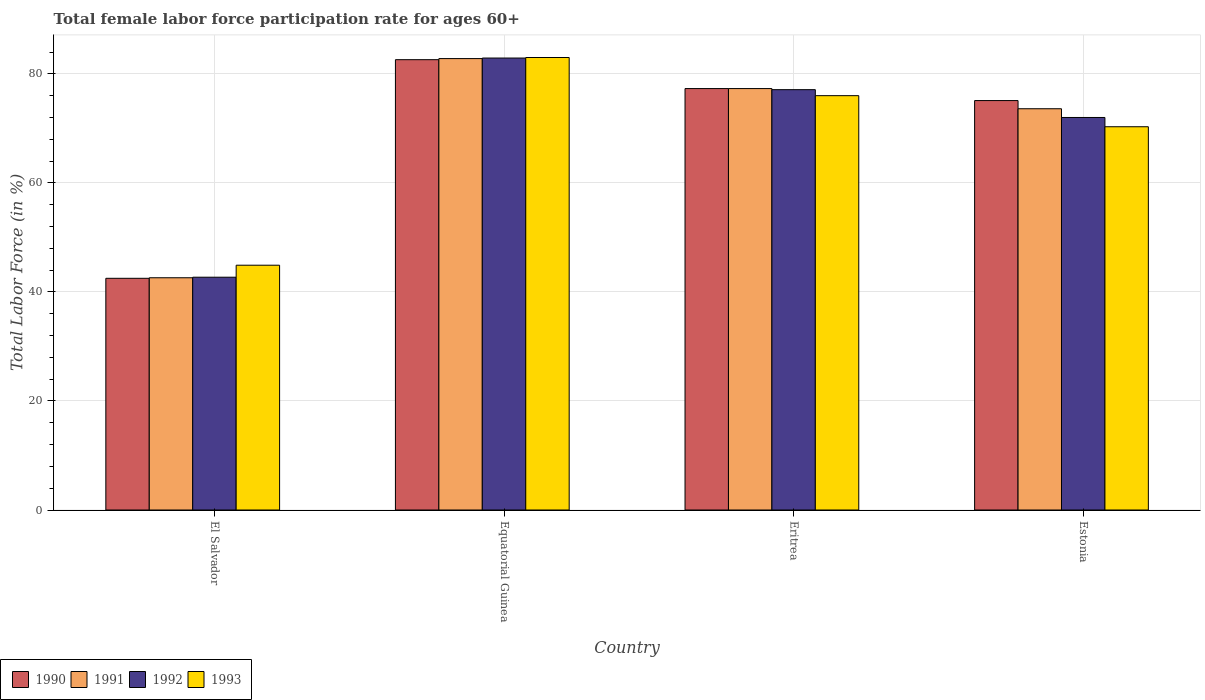How many different coloured bars are there?
Provide a succinct answer. 4. How many groups of bars are there?
Your answer should be compact. 4. Are the number of bars per tick equal to the number of legend labels?
Ensure brevity in your answer.  Yes. How many bars are there on the 1st tick from the right?
Offer a terse response. 4. What is the label of the 1st group of bars from the left?
Your answer should be very brief. El Salvador. In how many cases, is the number of bars for a given country not equal to the number of legend labels?
Offer a terse response. 0. What is the female labor force participation rate in 1992 in Equatorial Guinea?
Make the answer very short. 82.9. Across all countries, what is the minimum female labor force participation rate in 1990?
Your answer should be very brief. 42.5. In which country was the female labor force participation rate in 1990 maximum?
Offer a very short reply. Equatorial Guinea. In which country was the female labor force participation rate in 1993 minimum?
Your response must be concise. El Salvador. What is the total female labor force participation rate in 1992 in the graph?
Keep it short and to the point. 274.7. What is the difference between the female labor force participation rate in 1993 in El Salvador and that in Estonia?
Your answer should be compact. -25.4. What is the difference between the female labor force participation rate in 1992 in Estonia and the female labor force participation rate in 1990 in Eritrea?
Make the answer very short. -5.3. What is the average female labor force participation rate in 1993 per country?
Your response must be concise. 68.55. What is the difference between the female labor force participation rate of/in 1993 and female labor force participation rate of/in 1991 in Eritrea?
Give a very brief answer. -1.3. In how many countries, is the female labor force participation rate in 1993 greater than 28 %?
Give a very brief answer. 4. What is the ratio of the female labor force participation rate in 1993 in El Salvador to that in Estonia?
Provide a short and direct response. 0.64. Is the difference between the female labor force participation rate in 1993 in El Salvador and Estonia greater than the difference between the female labor force participation rate in 1991 in El Salvador and Estonia?
Your answer should be very brief. Yes. What is the difference between the highest and the second highest female labor force participation rate in 1993?
Provide a succinct answer. 7. What is the difference between the highest and the lowest female labor force participation rate in 1991?
Offer a very short reply. 40.2. Is the sum of the female labor force participation rate in 1991 in Equatorial Guinea and Eritrea greater than the maximum female labor force participation rate in 1992 across all countries?
Your answer should be compact. Yes. What does the 4th bar from the left in El Salvador represents?
Make the answer very short. 1993. Are all the bars in the graph horizontal?
Keep it short and to the point. No. How many countries are there in the graph?
Make the answer very short. 4. Does the graph contain any zero values?
Make the answer very short. No. Where does the legend appear in the graph?
Your answer should be compact. Bottom left. How many legend labels are there?
Offer a very short reply. 4. How are the legend labels stacked?
Your answer should be compact. Horizontal. What is the title of the graph?
Your answer should be very brief. Total female labor force participation rate for ages 60+. Does "1980" appear as one of the legend labels in the graph?
Keep it short and to the point. No. What is the label or title of the X-axis?
Ensure brevity in your answer.  Country. What is the Total Labor Force (in %) in 1990 in El Salvador?
Ensure brevity in your answer.  42.5. What is the Total Labor Force (in %) of 1991 in El Salvador?
Provide a short and direct response. 42.6. What is the Total Labor Force (in %) of 1992 in El Salvador?
Keep it short and to the point. 42.7. What is the Total Labor Force (in %) of 1993 in El Salvador?
Your response must be concise. 44.9. What is the Total Labor Force (in %) in 1990 in Equatorial Guinea?
Give a very brief answer. 82.6. What is the Total Labor Force (in %) in 1991 in Equatorial Guinea?
Your response must be concise. 82.8. What is the Total Labor Force (in %) of 1992 in Equatorial Guinea?
Your answer should be very brief. 82.9. What is the Total Labor Force (in %) in 1993 in Equatorial Guinea?
Give a very brief answer. 83. What is the Total Labor Force (in %) of 1990 in Eritrea?
Keep it short and to the point. 77.3. What is the Total Labor Force (in %) of 1991 in Eritrea?
Make the answer very short. 77.3. What is the Total Labor Force (in %) in 1992 in Eritrea?
Ensure brevity in your answer.  77.1. What is the Total Labor Force (in %) in 1990 in Estonia?
Provide a succinct answer. 75.1. What is the Total Labor Force (in %) in 1991 in Estonia?
Offer a terse response. 73.6. What is the Total Labor Force (in %) in 1992 in Estonia?
Ensure brevity in your answer.  72. What is the Total Labor Force (in %) in 1993 in Estonia?
Ensure brevity in your answer.  70.3. Across all countries, what is the maximum Total Labor Force (in %) of 1990?
Give a very brief answer. 82.6. Across all countries, what is the maximum Total Labor Force (in %) of 1991?
Make the answer very short. 82.8. Across all countries, what is the maximum Total Labor Force (in %) in 1992?
Your answer should be very brief. 82.9. Across all countries, what is the minimum Total Labor Force (in %) in 1990?
Ensure brevity in your answer.  42.5. Across all countries, what is the minimum Total Labor Force (in %) of 1991?
Provide a succinct answer. 42.6. Across all countries, what is the minimum Total Labor Force (in %) of 1992?
Keep it short and to the point. 42.7. Across all countries, what is the minimum Total Labor Force (in %) of 1993?
Your answer should be very brief. 44.9. What is the total Total Labor Force (in %) of 1990 in the graph?
Your response must be concise. 277.5. What is the total Total Labor Force (in %) in 1991 in the graph?
Provide a short and direct response. 276.3. What is the total Total Labor Force (in %) in 1992 in the graph?
Your response must be concise. 274.7. What is the total Total Labor Force (in %) of 1993 in the graph?
Provide a short and direct response. 274.2. What is the difference between the Total Labor Force (in %) in 1990 in El Salvador and that in Equatorial Guinea?
Offer a terse response. -40.1. What is the difference between the Total Labor Force (in %) of 1991 in El Salvador and that in Equatorial Guinea?
Ensure brevity in your answer.  -40.2. What is the difference between the Total Labor Force (in %) in 1992 in El Salvador and that in Equatorial Guinea?
Make the answer very short. -40.2. What is the difference between the Total Labor Force (in %) in 1993 in El Salvador and that in Equatorial Guinea?
Your answer should be very brief. -38.1. What is the difference between the Total Labor Force (in %) of 1990 in El Salvador and that in Eritrea?
Provide a short and direct response. -34.8. What is the difference between the Total Labor Force (in %) of 1991 in El Salvador and that in Eritrea?
Give a very brief answer. -34.7. What is the difference between the Total Labor Force (in %) in 1992 in El Salvador and that in Eritrea?
Give a very brief answer. -34.4. What is the difference between the Total Labor Force (in %) of 1993 in El Salvador and that in Eritrea?
Make the answer very short. -31.1. What is the difference between the Total Labor Force (in %) in 1990 in El Salvador and that in Estonia?
Your answer should be compact. -32.6. What is the difference between the Total Labor Force (in %) in 1991 in El Salvador and that in Estonia?
Your response must be concise. -31. What is the difference between the Total Labor Force (in %) in 1992 in El Salvador and that in Estonia?
Offer a terse response. -29.3. What is the difference between the Total Labor Force (in %) in 1993 in El Salvador and that in Estonia?
Give a very brief answer. -25.4. What is the difference between the Total Labor Force (in %) of 1990 in Equatorial Guinea and that in Eritrea?
Provide a short and direct response. 5.3. What is the difference between the Total Labor Force (in %) of 1991 in Equatorial Guinea and that in Eritrea?
Ensure brevity in your answer.  5.5. What is the difference between the Total Labor Force (in %) of 1992 in Equatorial Guinea and that in Eritrea?
Make the answer very short. 5.8. What is the difference between the Total Labor Force (in %) in 1991 in Equatorial Guinea and that in Estonia?
Make the answer very short. 9.2. What is the difference between the Total Labor Force (in %) of 1992 in Equatorial Guinea and that in Estonia?
Make the answer very short. 10.9. What is the difference between the Total Labor Force (in %) of 1990 in Eritrea and that in Estonia?
Your answer should be compact. 2.2. What is the difference between the Total Labor Force (in %) in 1993 in Eritrea and that in Estonia?
Offer a very short reply. 5.7. What is the difference between the Total Labor Force (in %) in 1990 in El Salvador and the Total Labor Force (in %) in 1991 in Equatorial Guinea?
Your answer should be very brief. -40.3. What is the difference between the Total Labor Force (in %) in 1990 in El Salvador and the Total Labor Force (in %) in 1992 in Equatorial Guinea?
Offer a very short reply. -40.4. What is the difference between the Total Labor Force (in %) of 1990 in El Salvador and the Total Labor Force (in %) of 1993 in Equatorial Guinea?
Offer a very short reply. -40.5. What is the difference between the Total Labor Force (in %) of 1991 in El Salvador and the Total Labor Force (in %) of 1992 in Equatorial Guinea?
Your answer should be very brief. -40.3. What is the difference between the Total Labor Force (in %) of 1991 in El Salvador and the Total Labor Force (in %) of 1993 in Equatorial Guinea?
Your response must be concise. -40.4. What is the difference between the Total Labor Force (in %) in 1992 in El Salvador and the Total Labor Force (in %) in 1993 in Equatorial Guinea?
Your answer should be very brief. -40.3. What is the difference between the Total Labor Force (in %) of 1990 in El Salvador and the Total Labor Force (in %) of 1991 in Eritrea?
Make the answer very short. -34.8. What is the difference between the Total Labor Force (in %) of 1990 in El Salvador and the Total Labor Force (in %) of 1992 in Eritrea?
Your response must be concise. -34.6. What is the difference between the Total Labor Force (in %) of 1990 in El Salvador and the Total Labor Force (in %) of 1993 in Eritrea?
Your answer should be very brief. -33.5. What is the difference between the Total Labor Force (in %) in 1991 in El Salvador and the Total Labor Force (in %) in 1992 in Eritrea?
Provide a short and direct response. -34.5. What is the difference between the Total Labor Force (in %) of 1991 in El Salvador and the Total Labor Force (in %) of 1993 in Eritrea?
Your answer should be very brief. -33.4. What is the difference between the Total Labor Force (in %) in 1992 in El Salvador and the Total Labor Force (in %) in 1993 in Eritrea?
Your answer should be compact. -33.3. What is the difference between the Total Labor Force (in %) in 1990 in El Salvador and the Total Labor Force (in %) in 1991 in Estonia?
Offer a very short reply. -31.1. What is the difference between the Total Labor Force (in %) of 1990 in El Salvador and the Total Labor Force (in %) of 1992 in Estonia?
Make the answer very short. -29.5. What is the difference between the Total Labor Force (in %) of 1990 in El Salvador and the Total Labor Force (in %) of 1993 in Estonia?
Ensure brevity in your answer.  -27.8. What is the difference between the Total Labor Force (in %) in 1991 in El Salvador and the Total Labor Force (in %) in 1992 in Estonia?
Your answer should be very brief. -29.4. What is the difference between the Total Labor Force (in %) in 1991 in El Salvador and the Total Labor Force (in %) in 1993 in Estonia?
Your answer should be very brief. -27.7. What is the difference between the Total Labor Force (in %) in 1992 in El Salvador and the Total Labor Force (in %) in 1993 in Estonia?
Your answer should be very brief. -27.6. What is the difference between the Total Labor Force (in %) in 1990 in Equatorial Guinea and the Total Labor Force (in %) in 1992 in Eritrea?
Provide a succinct answer. 5.5. What is the difference between the Total Labor Force (in %) in 1991 in Equatorial Guinea and the Total Labor Force (in %) in 1993 in Eritrea?
Your answer should be very brief. 6.8. What is the difference between the Total Labor Force (in %) in 1991 in Equatorial Guinea and the Total Labor Force (in %) in 1992 in Estonia?
Provide a short and direct response. 10.8. What is the difference between the Total Labor Force (in %) of 1990 in Eritrea and the Total Labor Force (in %) of 1992 in Estonia?
Your answer should be very brief. 5.3. What is the difference between the Total Labor Force (in %) in 1990 in Eritrea and the Total Labor Force (in %) in 1993 in Estonia?
Give a very brief answer. 7. What is the difference between the Total Labor Force (in %) in 1991 in Eritrea and the Total Labor Force (in %) in 1992 in Estonia?
Make the answer very short. 5.3. What is the difference between the Total Labor Force (in %) of 1991 in Eritrea and the Total Labor Force (in %) of 1993 in Estonia?
Ensure brevity in your answer.  7. What is the average Total Labor Force (in %) in 1990 per country?
Make the answer very short. 69.38. What is the average Total Labor Force (in %) of 1991 per country?
Your answer should be compact. 69.08. What is the average Total Labor Force (in %) of 1992 per country?
Offer a very short reply. 68.67. What is the average Total Labor Force (in %) in 1993 per country?
Provide a short and direct response. 68.55. What is the difference between the Total Labor Force (in %) in 1990 and Total Labor Force (in %) in 1992 in El Salvador?
Your response must be concise. -0.2. What is the difference between the Total Labor Force (in %) of 1990 and Total Labor Force (in %) of 1993 in El Salvador?
Offer a terse response. -2.4. What is the difference between the Total Labor Force (in %) in 1992 and Total Labor Force (in %) in 1993 in El Salvador?
Ensure brevity in your answer.  -2.2. What is the difference between the Total Labor Force (in %) in 1990 and Total Labor Force (in %) in 1991 in Equatorial Guinea?
Offer a terse response. -0.2. What is the difference between the Total Labor Force (in %) in 1990 and Total Labor Force (in %) in 1992 in Equatorial Guinea?
Give a very brief answer. -0.3. What is the difference between the Total Labor Force (in %) in 1990 and Total Labor Force (in %) in 1993 in Equatorial Guinea?
Ensure brevity in your answer.  -0.4. What is the difference between the Total Labor Force (in %) of 1991 and Total Labor Force (in %) of 1992 in Equatorial Guinea?
Your answer should be compact. -0.1. What is the difference between the Total Labor Force (in %) of 1990 and Total Labor Force (in %) of 1992 in Eritrea?
Your response must be concise. 0.2. What is the difference between the Total Labor Force (in %) in 1990 and Total Labor Force (in %) in 1993 in Eritrea?
Offer a terse response. 1.3. What is the difference between the Total Labor Force (in %) in 1990 and Total Labor Force (in %) in 1992 in Estonia?
Make the answer very short. 3.1. What is the difference between the Total Labor Force (in %) of 1990 and Total Labor Force (in %) of 1993 in Estonia?
Your answer should be compact. 4.8. What is the difference between the Total Labor Force (in %) in 1992 and Total Labor Force (in %) in 1993 in Estonia?
Provide a succinct answer. 1.7. What is the ratio of the Total Labor Force (in %) of 1990 in El Salvador to that in Equatorial Guinea?
Keep it short and to the point. 0.51. What is the ratio of the Total Labor Force (in %) of 1991 in El Salvador to that in Equatorial Guinea?
Provide a short and direct response. 0.51. What is the ratio of the Total Labor Force (in %) of 1992 in El Salvador to that in Equatorial Guinea?
Keep it short and to the point. 0.52. What is the ratio of the Total Labor Force (in %) of 1993 in El Salvador to that in Equatorial Guinea?
Ensure brevity in your answer.  0.54. What is the ratio of the Total Labor Force (in %) in 1990 in El Salvador to that in Eritrea?
Make the answer very short. 0.55. What is the ratio of the Total Labor Force (in %) of 1991 in El Salvador to that in Eritrea?
Make the answer very short. 0.55. What is the ratio of the Total Labor Force (in %) in 1992 in El Salvador to that in Eritrea?
Your answer should be compact. 0.55. What is the ratio of the Total Labor Force (in %) in 1993 in El Salvador to that in Eritrea?
Ensure brevity in your answer.  0.59. What is the ratio of the Total Labor Force (in %) in 1990 in El Salvador to that in Estonia?
Your answer should be compact. 0.57. What is the ratio of the Total Labor Force (in %) of 1991 in El Salvador to that in Estonia?
Provide a short and direct response. 0.58. What is the ratio of the Total Labor Force (in %) in 1992 in El Salvador to that in Estonia?
Offer a very short reply. 0.59. What is the ratio of the Total Labor Force (in %) in 1993 in El Salvador to that in Estonia?
Your answer should be very brief. 0.64. What is the ratio of the Total Labor Force (in %) in 1990 in Equatorial Guinea to that in Eritrea?
Your answer should be very brief. 1.07. What is the ratio of the Total Labor Force (in %) in 1991 in Equatorial Guinea to that in Eritrea?
Ensure brevity in your answer.  1.07. What is the ratio of the Total Labor Force (in %) in 1992 in Equatorial Guinea to that in Eritrea?
Ensure brevity in your answer.  1.08. What is the ratio of the Total Labor Force (in %) of 1993 in Equatorial Guinea to that in Eritrea?
Provide a succinct answer. 1.09. What is the ratio of the Total Labor Force (in %) in 1990 in Equatorial Guinea to that in Estonia?
Provide a short and direct response. 1.1. What is the ratio of the Total Labor Force (in %) of 1991 in Equatorial Guinea to that in Estonia?
Provide a succinct answer. 1.12. What is the ratio of the Total Labor Force (in %) in 1992 in Equatorial Guinea to that in Estonia?
Offer a terse response. 1.15. What is the ratio of the Total Labor Force (in %) of 1993 in Equatorial Guinea to that in Estonia?
Your response must be concise. 1.18. What is the ratio of the Total Labor Force (in %) of 1990 in Eritrea to that in Estonia?
Keep it short and to the point. 1.03. What is the ratio of the Total Labor Force (in %) in 1991 in Eritrea to that in Estonia?
Offer a terse response. 1.05. What is the ratio of the Total Labor Force (in %) of 1992 in Eritrea to that in Estonia?
Provide a short and direct response. 1.07. What is the ratio of the Total Labor Force (in %) of 1993 in Eritrea to that in Estonia?
Offer a very short reply. 1.08. What is the difference between the highest and the second highest Total Labor Force (in %) of 1991?
Your answer should be compact. 5.5. What is the difference between the highest and the lowest Total Labor Force (in %) of 1990?
Ensure brevity in your answer.  40.1. What is the difference between the highest and the lowest Total Labor Force (in %) of 1991?
Your answer should be compact. 40.2. What is the difference between the highest and the lowest Total Labor Force (in %) of 1992?
Keep it short and to the point. 40.2. What is the difference between the highest and the lowest Total Labor Force (in %) in 1993?
Ensure brevity in your answer.  38.1. 